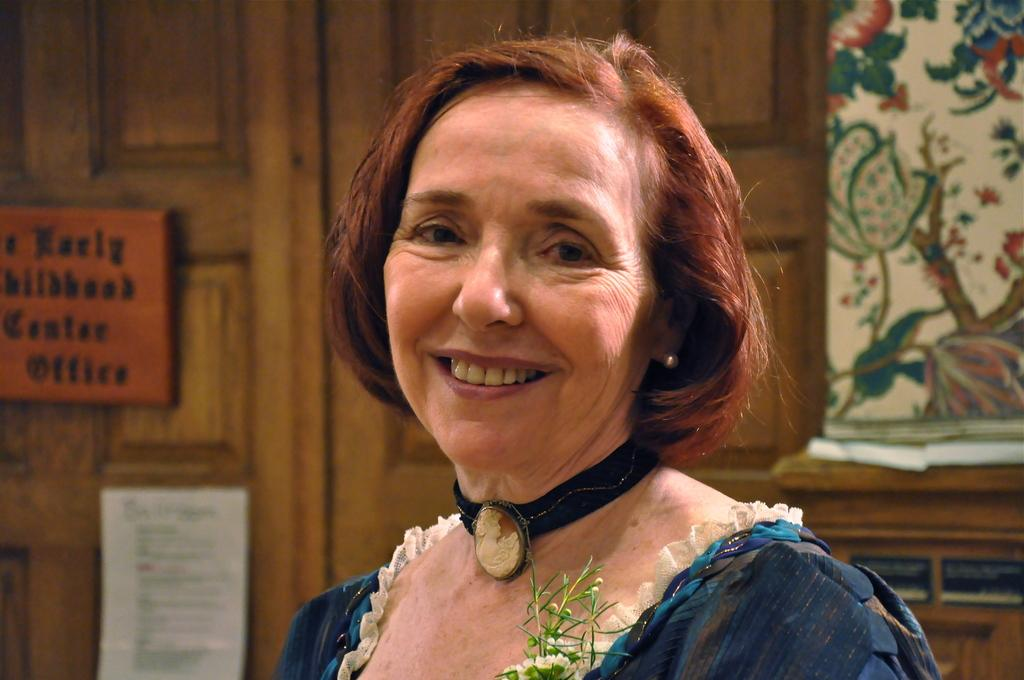What is the main subject in the foreground of the image? There is a woman in the foreground of the image. What can be seen in the background of the image? There is a wooden wall, wall paintings, and boards in the background of the image. What type of structure might the wooden wall and wall paintings be a part of? The wooden wall and wall paintings may be part of a hall, as suggested by the image. What type of key is used to open the gate in the image? There is no gate present in the image, so there is no key to open it. What type of battle is depicted in the wall paintings in the image? The wall paintings in the image do not depict a battle; they are not described in the provided facts. 